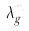<formula> <loc_0><loc_0><loc_500><loc_500>\lambda _ { g } ^ { m }</formula> 